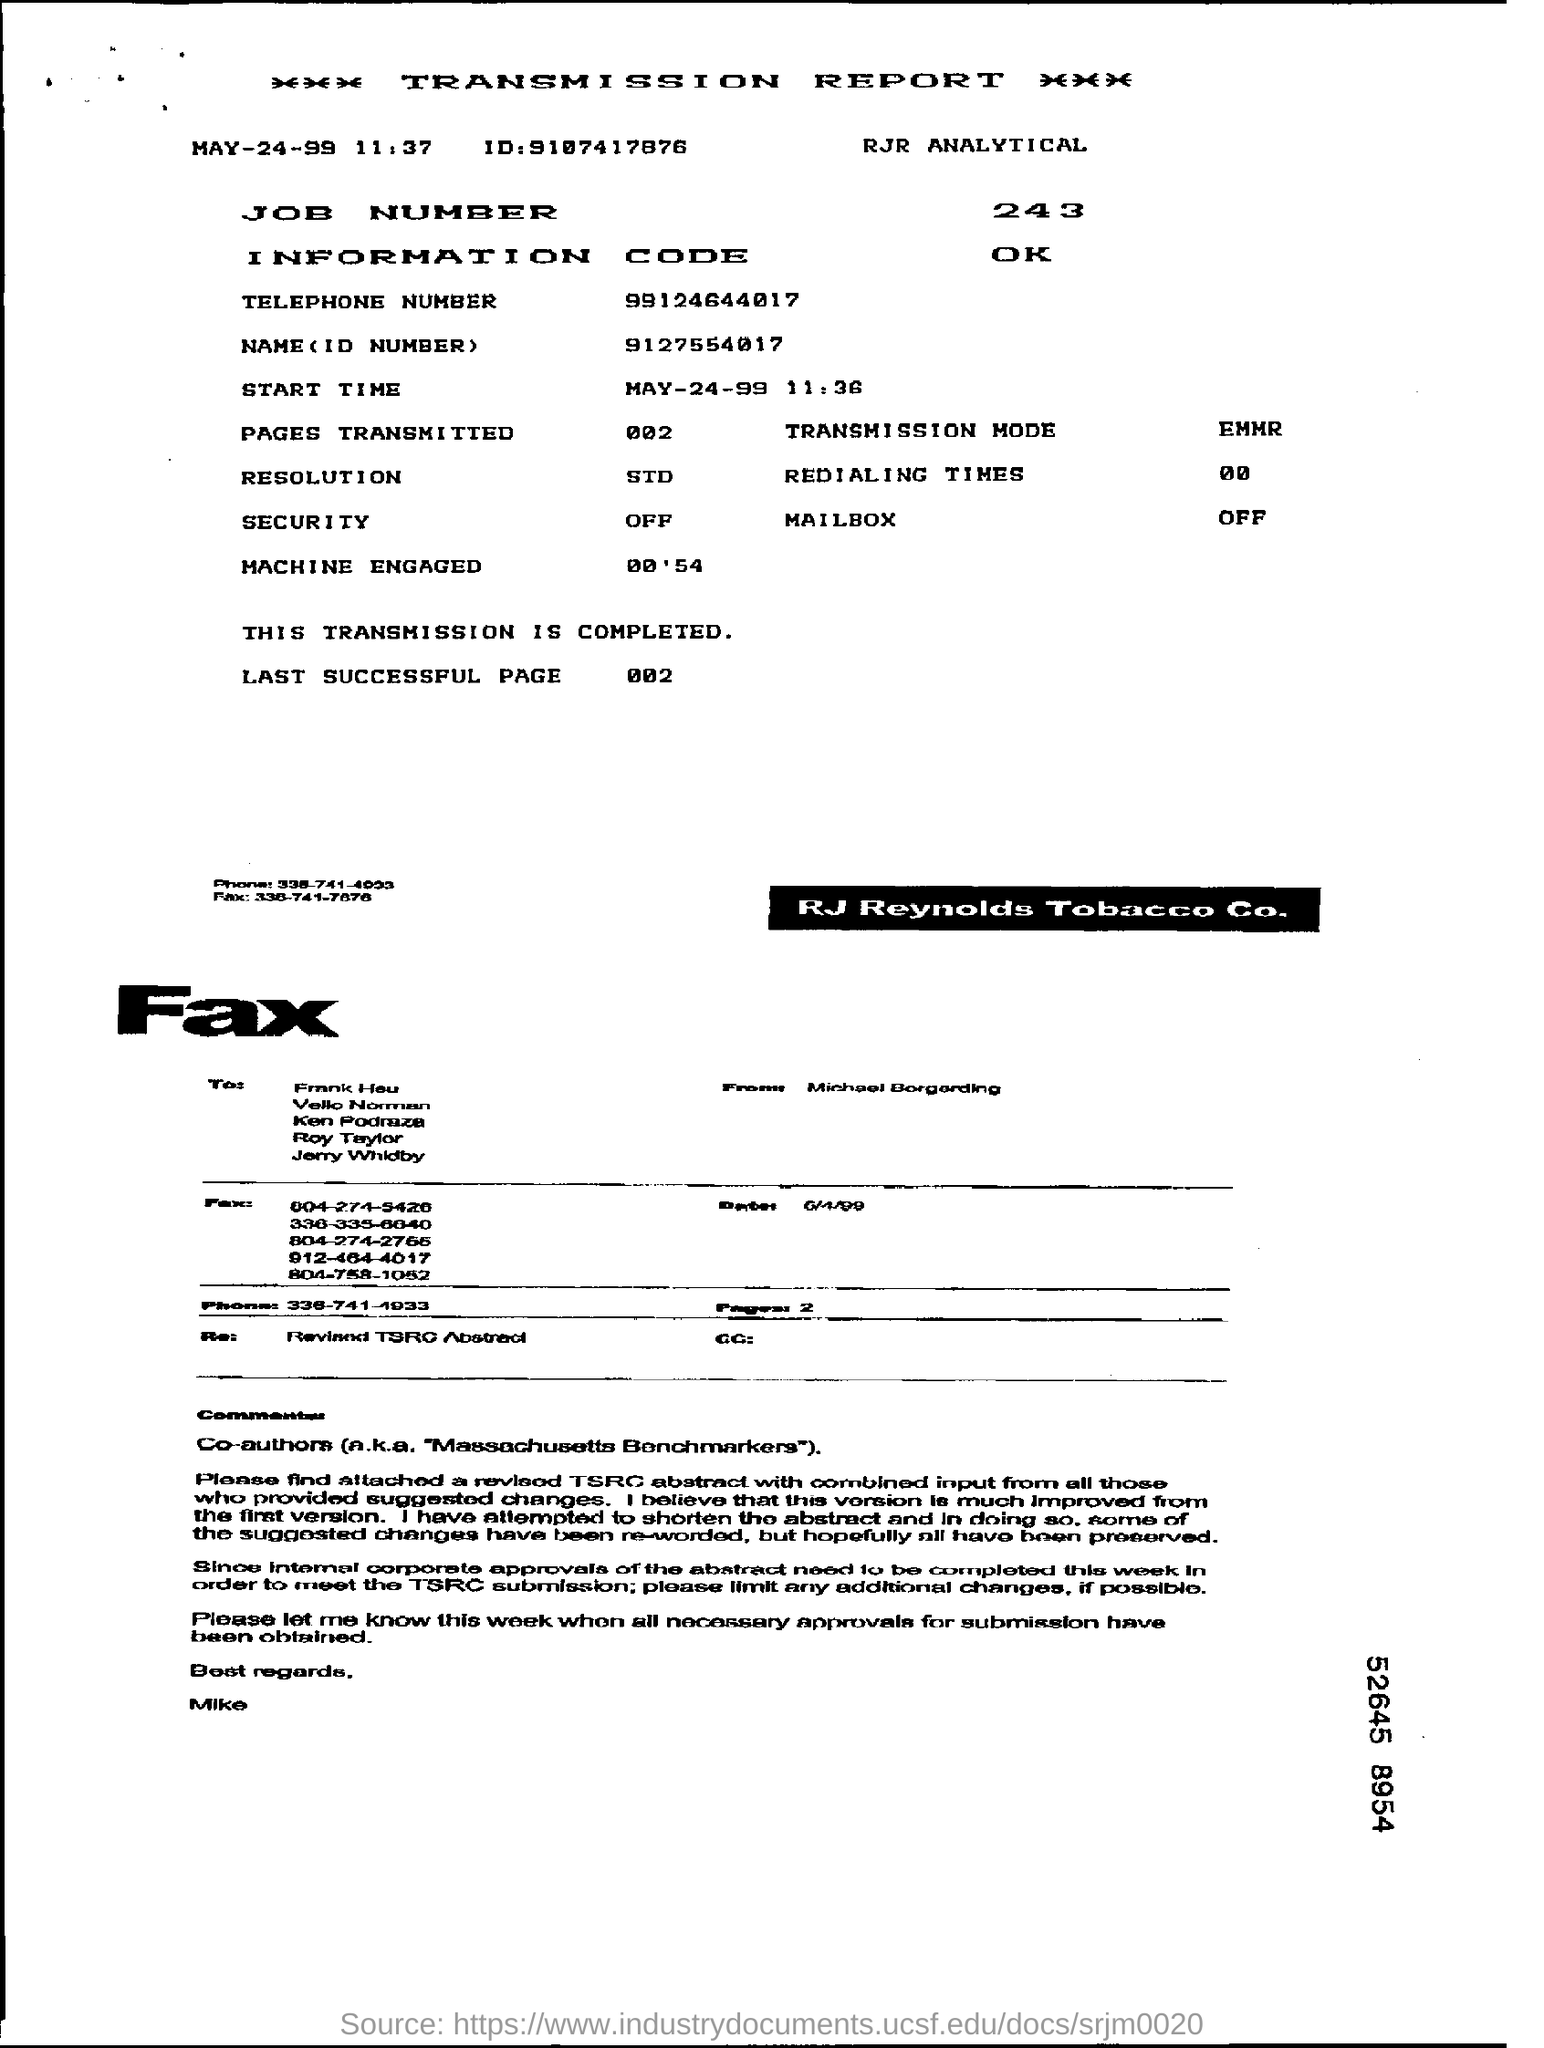Outline some significant characteristics in this image. The ID mentioned is 9107417876... The telephone number mentioned is 99124644017... 